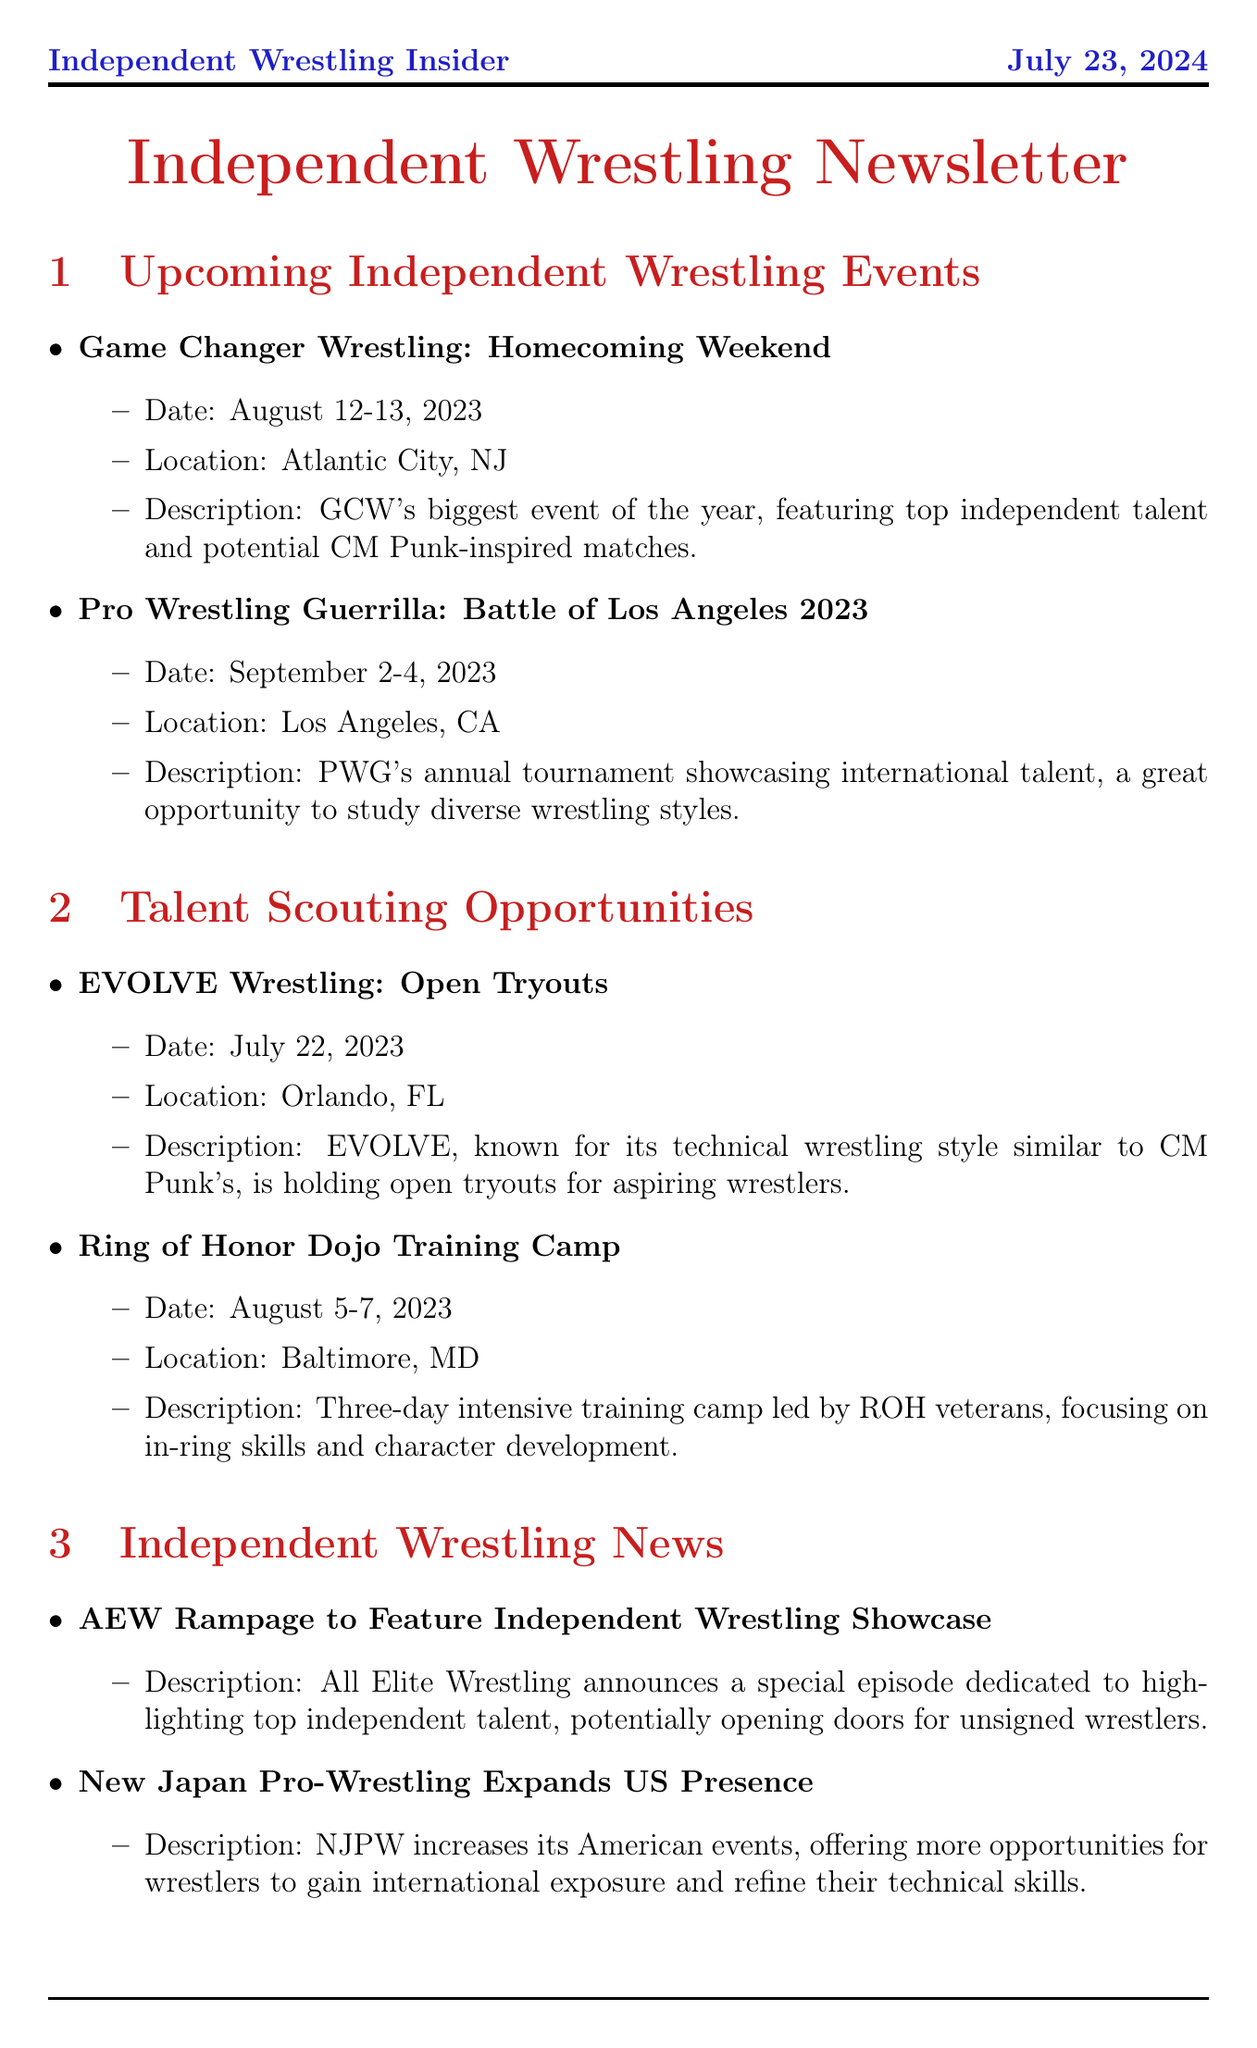What is the date of the Game Changer Wrestling event? The document states that the Game Changer Wrestling event will take place on August 12-13, 2023.
Answer: August 12-13, 2023 Where is the Pro Wrestling Guerrilla event located? According to the newsletter, the Pro Wrestling Guerrilla event is in Los Angeles, CA.
Answer: Los Angeles, CA What type of wrestling style does EVOLVE Wrestling focus on? The content in the document describes EVOLVE as having a technical wrestling style similar to CM Punk's.
Answer: Technical What is the focus of the Ring of Honor Dojo Training Camp? The document indicates that the focus of the Ring of Honor Dojo Training Camp is on in-ring skills and character development.
Answer: In-ring skills and character development How many days is the Game Changer Wrestling event? The newsletter mentions that the Game Changer Wrestling event spans two days.
Answer: Two days What special feature will AEW Rampage include? The document mentions that AEW Rampage will feature an independent wrestling showcase.
Answer: Independent wrestling showcase What is one of the tips for training inspired by CM Punk? The newsletter provides various training tips, one of which is to develop mic skills.
Answer: Develop mic skills Which promotion is known for innovative matchmaking? The document identifies Beyond Wrestling as known for its innovative matchmaking.
Answer: Beyond Wrestling 